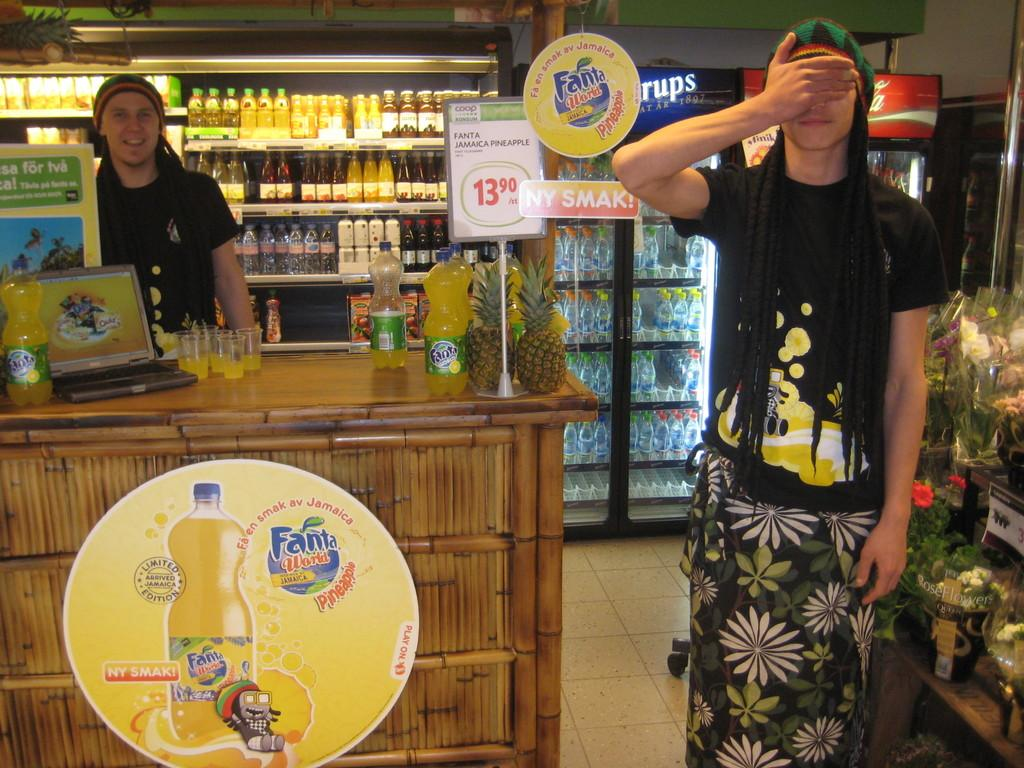<image>
Give a short and clear explanation of the subsequent image. A man standing in a convenience store in front of a yellow circular advertisement for Fanta World 